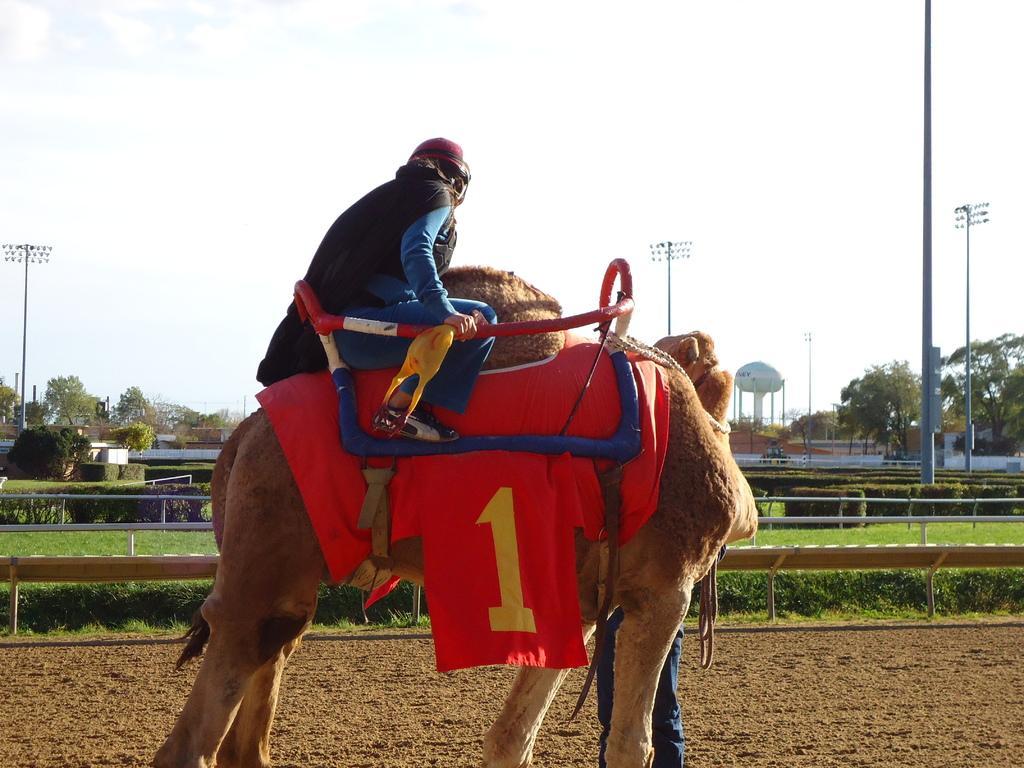Can you describe this image briefly? In this picture we can see a person sitting on an animal. There is a red cloth and a number is visible on this cloth. We can see a few rods. There is a fence from left to right. Some grass is visible on the ground. There are a few trees, poles and a white object is visible in the background. 